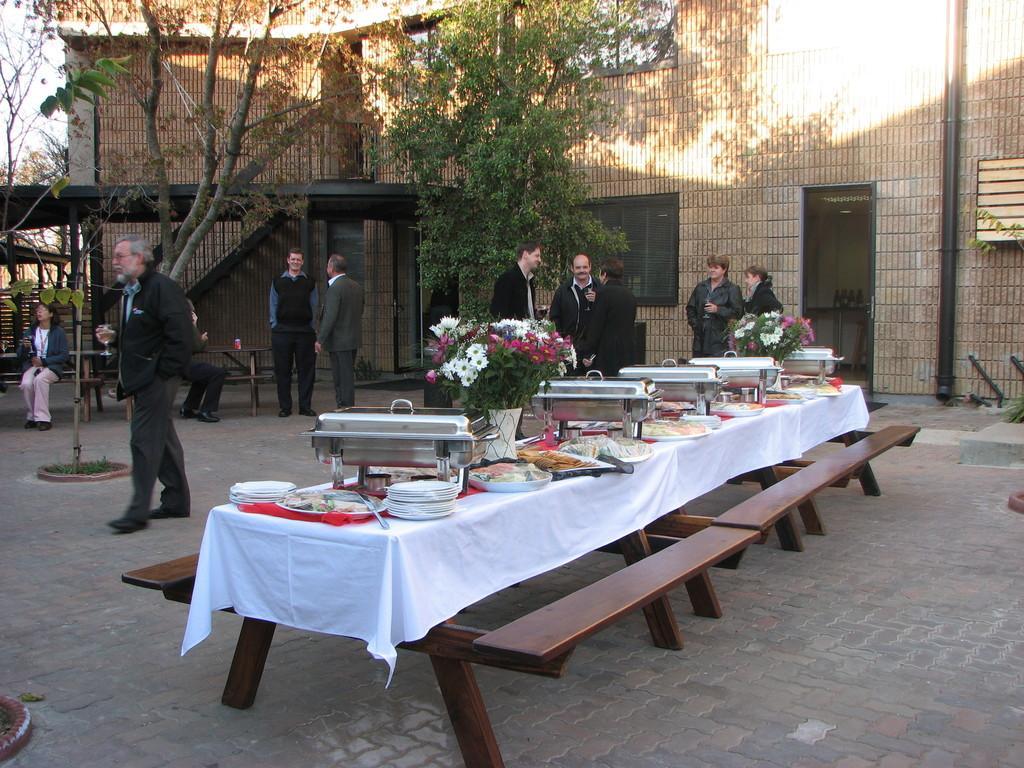Describe this image in one or two sentences. The picture is taken outside of the building where number of people standing and talking, at the center of the picture there is one big table and benches on the table, there are food items,plates and cups and two flower vases are there. There are trees behind the people and stairs behind them. On the left corner of the picture one person is sitting on the bench. 